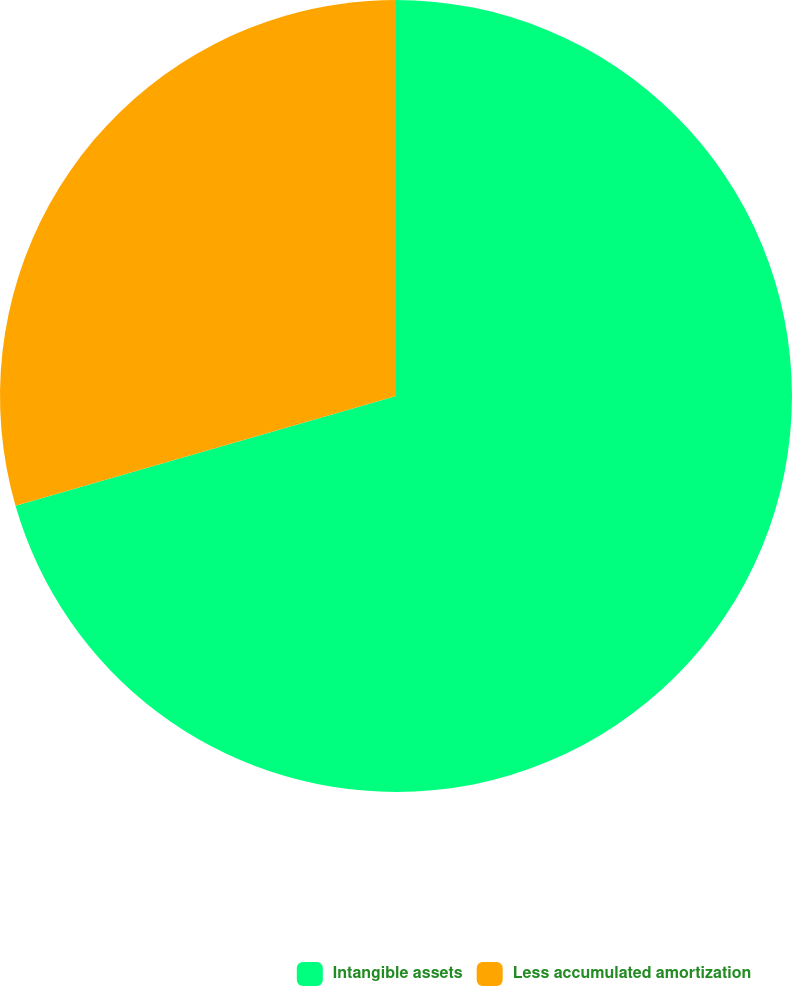Convert chart to OTSL. <chart><loc_0><loc_0><loc_500><loc_500><pie_chart><fcel>Intangible assets<fcel>Less accumulated amortization<nl><fcel>70.53%<fcel>29.47%<nl></chart> 